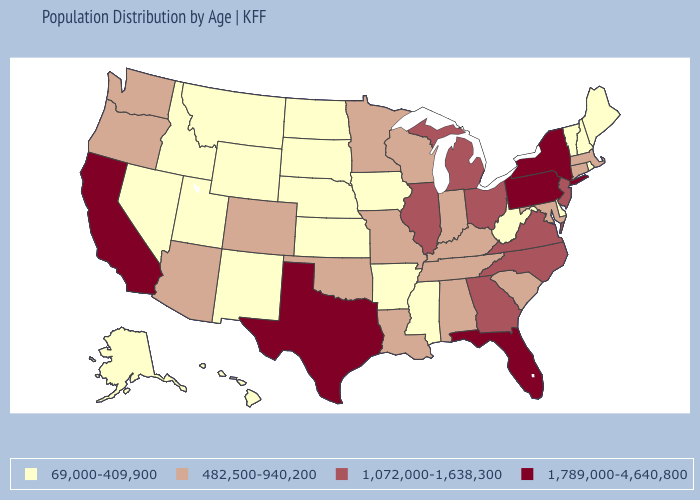Does Tennessee have a lower value than Georgia?
Write a very short answer. Yes. Among the states that border South Dakota , does Minnesota have the highest value?
Answer briefly. Yes. Name the states that have a value in the range 1,072,000-1,638,300?
Quick response, please. Georgia, Illinois, Michigan, New Jersey, North Carolina, Ohio, Virginia. Does California have the highest value in the West?
Concise answer only. Yes. How many symbols are there in the legend?
Short answer required. 4. What is the value of Tennessee?
Answer briefly. 482,500-940,200. Which states hav the highest value in the MidWest?
Keep it brief. Illinois, Michigan, Ohio. Does Arkansas have a lower value than Tennessee?
Short answer required. Yes. What is the highest value in the USA?
Write a very short answer. 1,789,000-4,640,800. What is the lowest value in the South?
Keep it brief. 69,000-409,900. Which states have the highest value in the USA?
Write a very short answer. California, Florida, New York, Pennsylvania, Texas. Does New York have the lowest value in the USA?
Be succinct. No. What is the value of Iowa?
Short answer required. 69,000-409,900. What is the highest value in states that border Minnesota?
Short answer required. 482,500-940,200. 